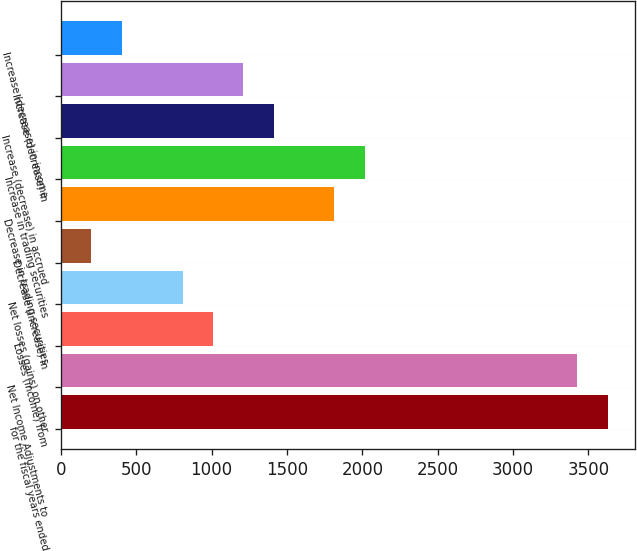Convert chart to OTSL. <chart><loc_0><loc_0><loc_500><loc_500><bar_chart><fcel>for the fiscal years ended<fcel>Net Income Adjustments to<fcel>Losses (income) from<fcel>Net losses (gains) on other<fcel>Decrease (increase) in<fcel>Decrease in trading securities<fcel>Increase in trading securities<fcel>Increase (decrease) in accrued<fcel>Increase (decrease) in<fcel>Increase (decrease) in income<nl><fcel>3628.16<fcel>3426.64<fcel>1008.4<fcel>806.88<fcel>202.32<fcel>1814.48<fcel>2016<fcel>1411.44<fcel>1209.92<fcel>403.84<nl></chart> 